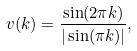<formula> <loc_0><loc_0><loc_500><loc_500>v ( k ) = \frac { \sin ( 2 \pi k ) } { | \sin ( \pi k ) | } ,</formula> 